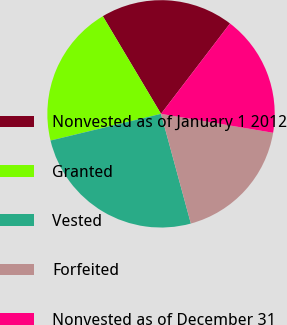Convert chart to OTSL. <chart><loc_0><loc_0><loc_500><loc_500><pie_chart><fcel>Nonvested as of January 1 2012<fcel>Granted<fcel>Vested<fcel>Forfeited<fcel>Nonvested as of December 31<nl><fcel>18.93%<fcel>20.22%<fcel>25.45%<fcel>18.11%<fcel>17.29%<nl></chart> 